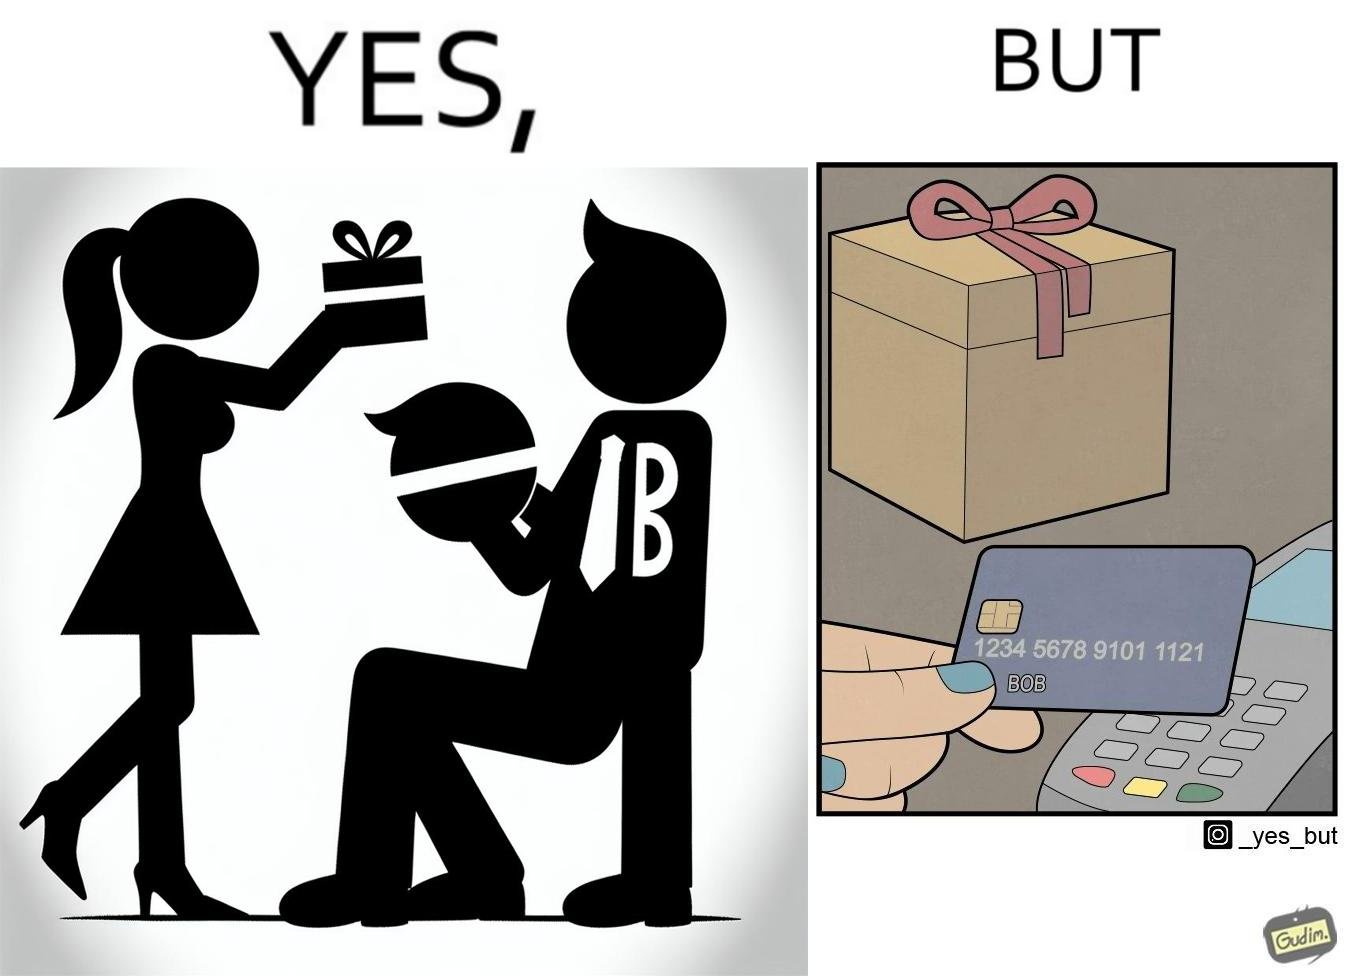Compare the left and right sides of this image. In the left part of the image: A woman covers the eyes of a man named Bob, while gifting something to him. In the right part of the image: Someone is holding a credit/debit card near a card machine, which has been used to buy the gift that can be seen placed near the card machine. 